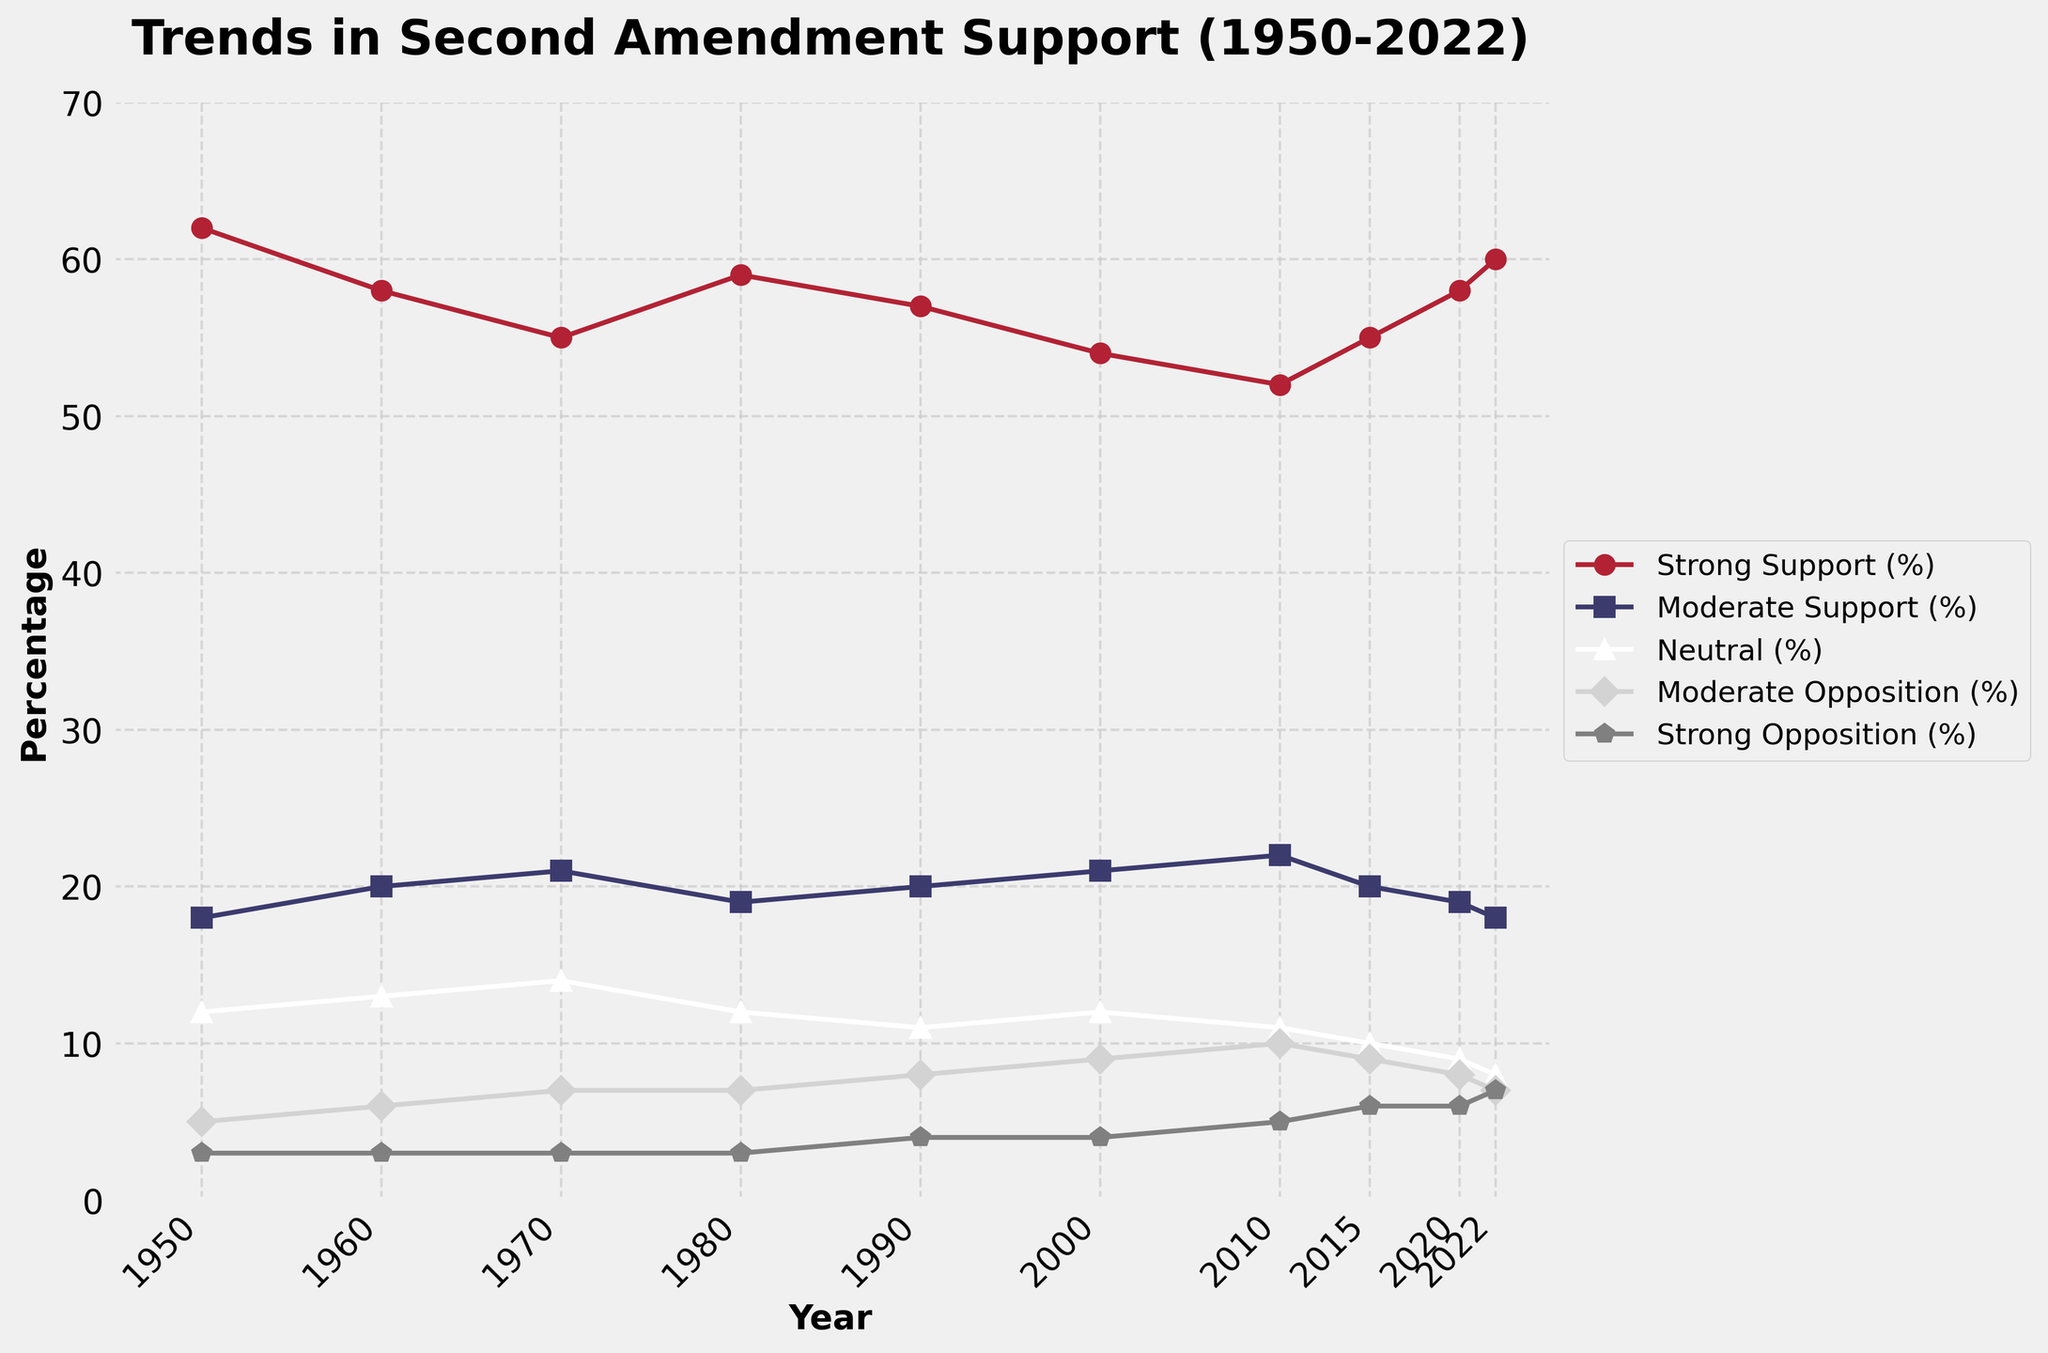What is the percentage of Strong Support in 1980? Look for the point corresponding to the year 1980 on the line representing Strong Support and read the value.
Answer: 59% How has the percentage of Strong Support changed from 1950 to 2022? Identify the Strong Support percentage in 1950 (62%) and in 2022 (60%), then calculate the difference: 60% - 62% = -2%.
Answer: -2% What is the average percentage of Moderate Support from 1950 to 2022? Sum the percentages of Moderate Support for all provided years (18+20+21+19+20+21+22+20+19+18) = 198 and divide by the number of years (10): 198/10 = 19.8.
Answer: 19.8% In which year did the Neutral percentage peak, and what was its value? Identify the highest point on the line representing Neutral percentage and note the corresponding year. The peak value of 14% was in 1970.
Answer: 1970, 14% Compare the Moderate Opposition percentage in 2000 and 2020. Which year had a higher percentage? Locate the points for Moderate Opposition in 2000 (9%) and 2020 (8%), then compare the values.
Answer: 2000 Which support or opposition category consistently had the lowest percentage from 1950 to 2022? Compare the lowest points of each category across all years. The category with the lowest values throughout is Strong Opposition.
Answer: Strong Opposition What is the difference between the percentage of Strong Support and Strong Opposition in 2022? Identify both percentages for the year 2022 (Strong Support: 60%, Strong Opposition: 7%) and calculate the difference: 60% - 7%.
Answer: 53% How has Moderate Support percentage changed from 1990 to 2010? Identify the percentages for Moderate Support in 1990 (20%) and in 2010 (22%), then calculate the difference: 22% - 20%.
Answer: 2% What is the trend in Neutral percentage from 1950 to 2022? Observe the Neutral line over the years. The percentage starts at 12% in 1950 and gradually decreases to 8% by 2022.
Answer: Decreasing How has the percentage of Moderate Opposition changed over the decades from 1950 to 2022? Note the percentages for each decade: 1950 (5%), 1960 (6%), 1970 (7%), 1980 (7%), 1990 (8%), 2000 (9%), 2010 (10%), 2015 (9%), 2020 (8%), 2022 (7%). The percentage generally increases until 2010 and then starts decreasing.
Answer: Generally increased to 2010, then decreased 